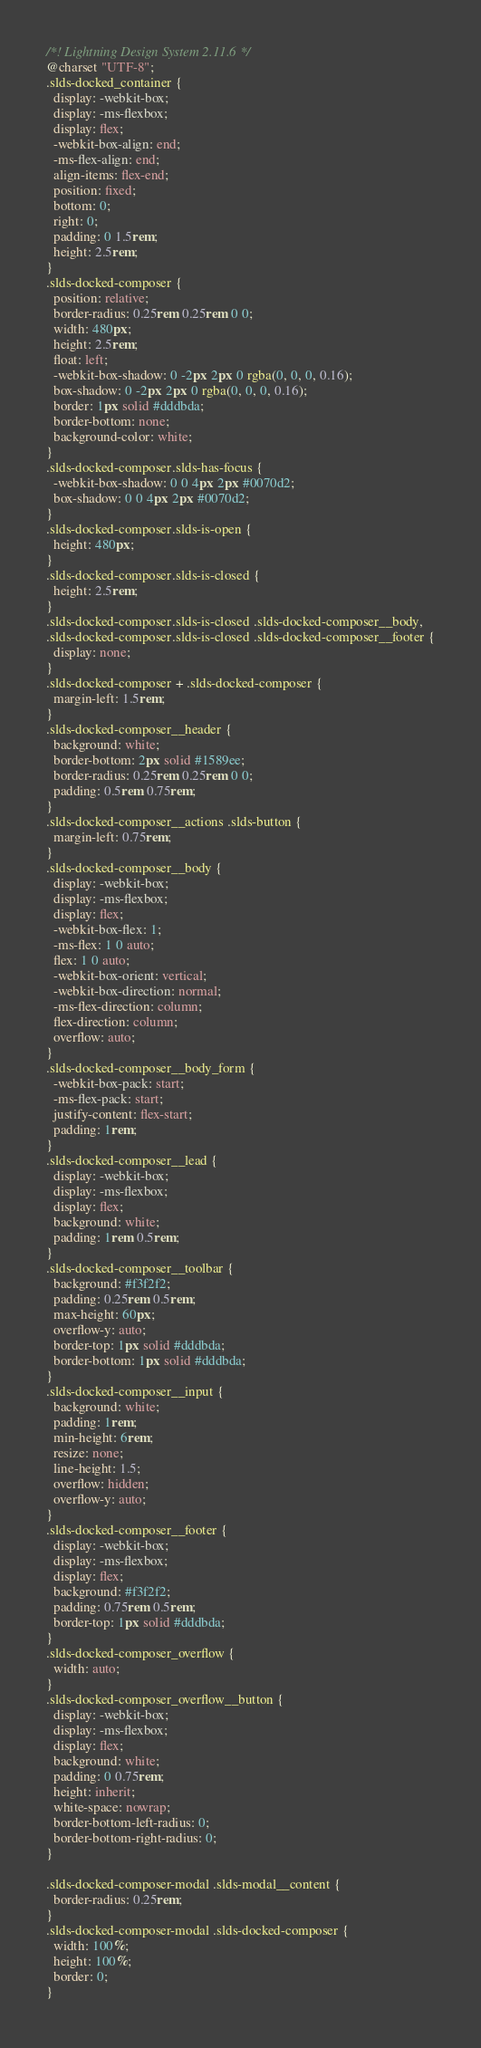Convert code to text. <code><loc_0><loc_0><loc_500><loc_500><_CSS_>/*! Lightning Design System 2.11.6 */
@charset "UTF-8";
.slds-docked_container {
  display: -webkit-box;
  display: -ms-flexbox;
  display: flex;
  -webkit-box-align: end;
  -ms-flex-align: end;
  align-items: flex-end;
  position: fixed;
  bottom: 0;
  right: 0;
  padding: 0 1.5rem;
  height: 2.5rem;
}
.slds-docked-composer {
  position: relative;
  border-radius: 0.25rem 0.25rem 0 0;
  width: 480px;
  height: 2.5rem;
  float: left;
  -webkit-box-shadow: 0 -2px 2px 0 rgba(0, 0, 0, 0.16);
  box-shadow: 0 -2px 2px 0 rgba(0, 0, 0, 0.16);
  border: 1px solid #dddbda;
  border-bottom: none;
  background-color: white;
}
.slds-docked-composer.slds-has-focus {
  -webkit-box-shadow: 0 0 4px 2px #0070d2;
  box-shadow: 0 0 4px 2px #0070d2;
}
.slds-docked-composer.slds-is-open {
  height: 480px;
}
.slds-docked-composer.slds-is-closed {
  height: 2.5rem;
}
.slds-docked-composer.slds-is-closed .slds-docked-composer__body,
.slds-docked-composer.slds-is-closed .slds-docked-composer__footer {
  display: none;
}
.slds-docked-composer + .slds-docked-composer {
  margin-left: 1.5rem;
}
.slds-docked-composer__header {
  background: white;
  border-bottom: 2px solid #1589ee;
  border-radius: 0.25rem 0.25rem 0 0;
  padding: 0.5rem 0.75rem;
}
.slds-docked-composer__actions .slds-button {
  margin-left: 0.75rem;
}
.slds-docked-composer__body {
  display: -webkit-box;
  display: -ms-flexbox;
  display: flex;
  -webkit-box-flex: 1;
  -ms-flex: 1 0 auto;
  flex: 1 0 auto;
  -webkit-box-orient: vertical;
  -webkit-box-direction: normal;
  -ms-flex-direction: column;
  flex-direction: column;
  overflow: auto;
}
.slds-docked-composer__body_form {
  -webkit-box-pack: start;
  -ms-flex-pack: start;
  justify-content: flex-start;
  padding: 1rem;
}
.slds-docked-composer__lead {
  display: -webkit-box;
  display: -ms-flexbox;
  display: flex;
  background: white;
  padding: 1rem 0.5rem;
}
.slds-docked-composer__toolbar {
  background: #f3f2f2;
  padding: 0.25rem 0.5rem;
  max-height: 60px;
  overflow-y: auto;
  border-top: 1px solid #dddbda;
  border-bottom: 1px solid #dddbda;
}
.slds-docked-composer__input {
  background: white;
  padding: 1rem;
  min-height: 6rem;
  resize: none;
  line-height: 1.5;
  overflow: hidden;
  overflow-y: auto;
}
.slds-docked-composer__footer {
  display: -webkit-box;
  display: -ms-flexbox;
  display: flex;
  background: #f3f2f2;
  padding: 0.75rem 0.5rem;
  border-top: 1px solid #dddbda;
}
.slds-docked-composer_overflow {
  width: auto;
}
.slds-docked-composer_overflow__button {
  display: -webkit-box;
  display: -ms-flexbox;
  display: flex;
  background: white;
  padding: 0 0.75rem;
  height: inherit;
  white-space: nowrap;
  border-bottom-left-radius: 0;
  border-bottom-right-radius: 0;
}

.slds-docked-composer-modal .slds-modal__content {
  border-radius: 0.25rem;
}
.slds-docked-composer-modal .slds-docked-composer {
  width: 100%;
  height: 100%;
  border: 0;
}
</code> 